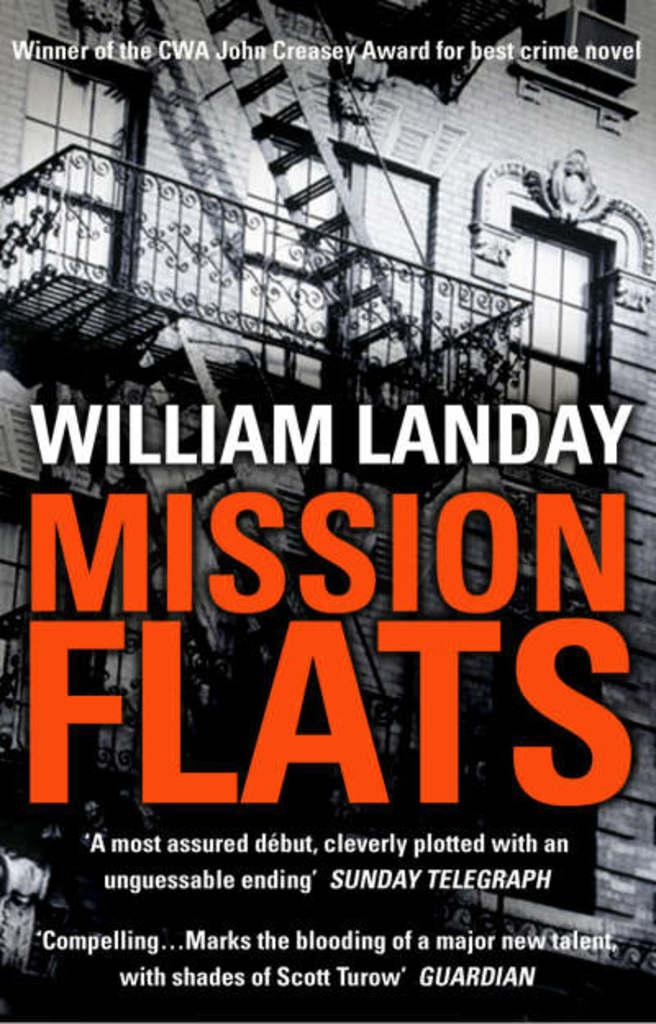Provide a one-sentence caption for the provided image. A book called Mission Flats from author William Landy showing and old building with an attached staircase outside on the front cover of the book. 